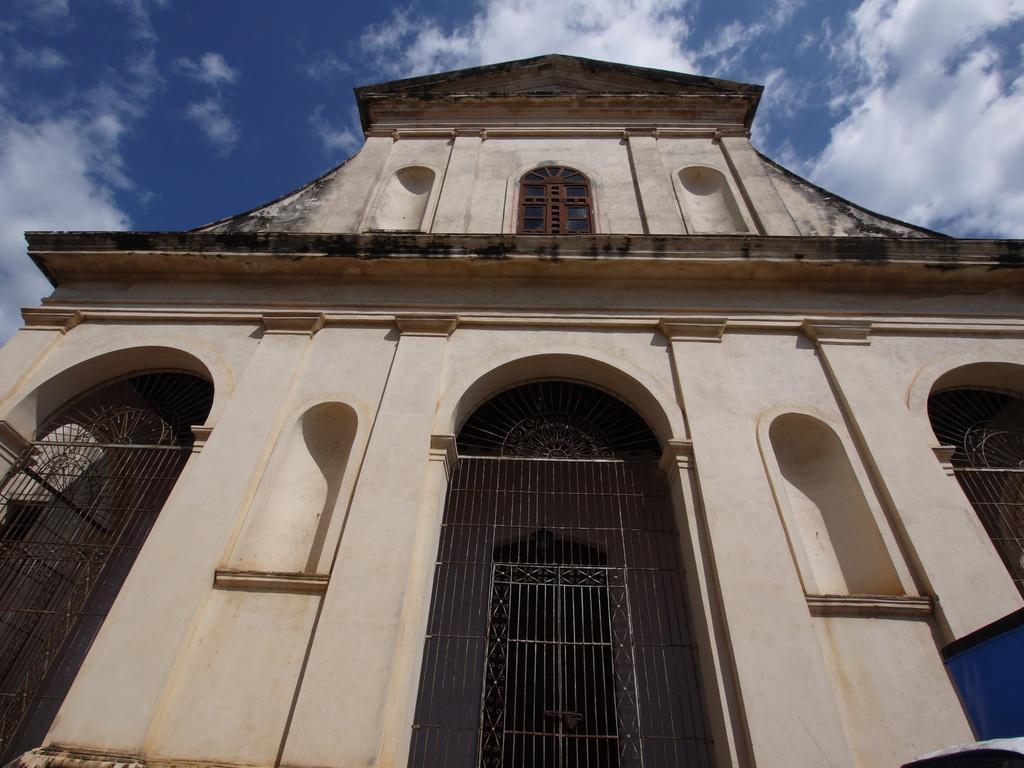Can you describe this image briefly? In this picture I can see the building. I can see clouds in the sky. 